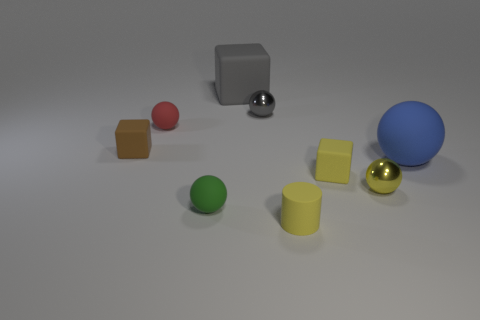Subtract all balls. How many objects are left? 4 Subtract 1 cylinders. How many cylinders are left? 0 Subtract all purple cylinders. Subtract all blue blocks. How many cylinders are left? 1 Subtract all red cylinders. How many brown cubes are left? 1 Subtract all green spheres. Subtract all big blue objects. How many objects are left? 7 Add 5 tiny yellow shiny things. How many tiny yellow shiny things are left? 6 Add 4 brown rubber objects. How many brown rubber objects exist? 5 Add 1 brown cubes. How many objects exist? 10 Subtract all green spheres. How many spheres are left? 4 Subtract all small green rubber spheres. How many spheres are left? 4 